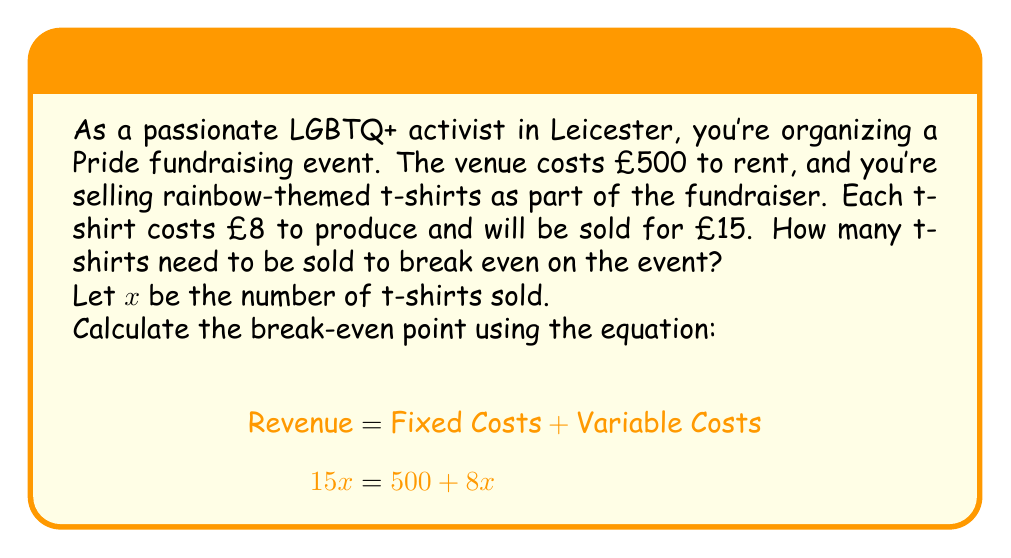Could you help me with this problem? To solve this problem, we'll use the break-even equation:

$$\text{Revenue} = \text{Fixed Costs} + \text{Variable Costs}$$

Let's break down the components:
1. Revenue: $15x$ (selling price per t-shirt × number of t-shirts)
2. Fixed Costs: £500 (venue rental)
3. Variable Costs: $8x$ (production cost per t-shirt × number of t-shirts)

Substituting these into the equation:

$$15x = 500 + 8x$$

Now, let's solve for $x$:

1. Subtract $8x$ from both sides:
   $$15x - 8x = 500 + 8x - 8x$$
   $$7x = 500$$

2. Divide both sides by 7:
   $$x = \frac{500}{7} \approx 71.43$$

Since we can't sell a fraction of a t-shirt, we need to round up to the nearest whole number.
Answer: The break-even point is 72 t-shirts. At this point, the revenue will exactly cover the fixed and variable costs of the event. 